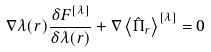<formula> <loc_0><loc_0><loc_500><loc_500>\nabla \lambda ( { r } ) \frac { \delta F ^ { [ \lambda ] } } { \delta \lambda ( { r } ) } + \nabla \left \langle \hat { \Pi } _ { r } \right \rangle ^ { [ \lambda ] } & = 0</formula> 